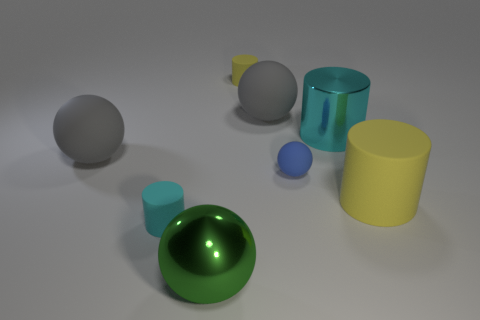Subtract 1 cylinders. How many cylinders are left? 3 Subtract all yellow spheres. Subtract all purple cylinders. How many spheres are left? 4 Add 2 large cyan metallic cylinders. How many objects exist? 10 Add 7 gray matte objects. How many gray matte objects exist? 9 Subtract 0 brown balls. How many objects are left? 8 Subtract all tiny green objects. Subtract all matte balls. How many objects are left? 5 Add 4 cyan shiny things. How many cyan shiny things are left? 5 